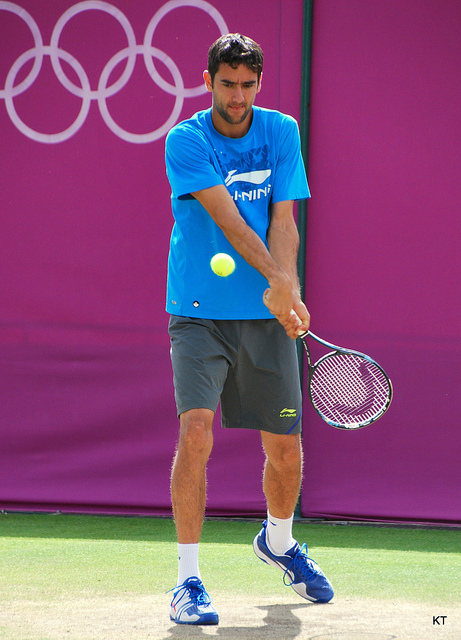Please identify all text content in this image. NIN KT 